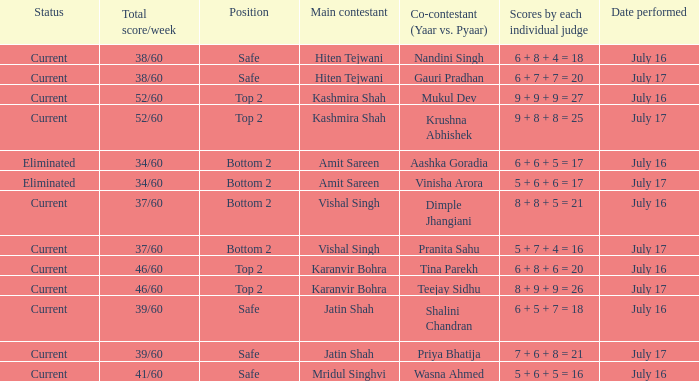Who performed with Tina Parekh? Karanvir Bohra. 